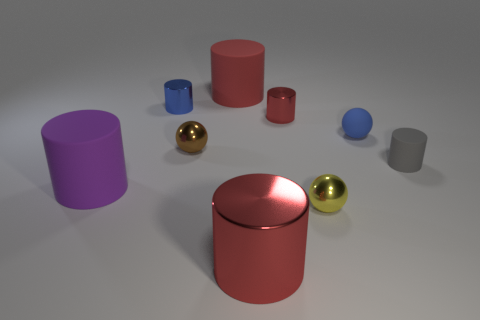How many red cylinders must be subtracted to get 2 red cylinders? 1 Subtract all brown cubes. How many red cylinders are left? 3 Subtract all tiny shiny cylinders. How many cylinders are left? 4 Subtract all gray cylinders. How many cylinders are left? 5 Subtract all spheres. How many objects are left? 6 Subtract all large yellow cubes. Subtract all blue things. How many objects are left? 7 Add 1 brown objects. How many brown objects are left? 2 Add 5 small gray matte cubes. How many small gray matte cubes exist? 5 Subtract 1 blue cylinders. How many objects are left? 8 Subtract all yellow balls. Subtract all cyan cubes. How many balls are left? 2 